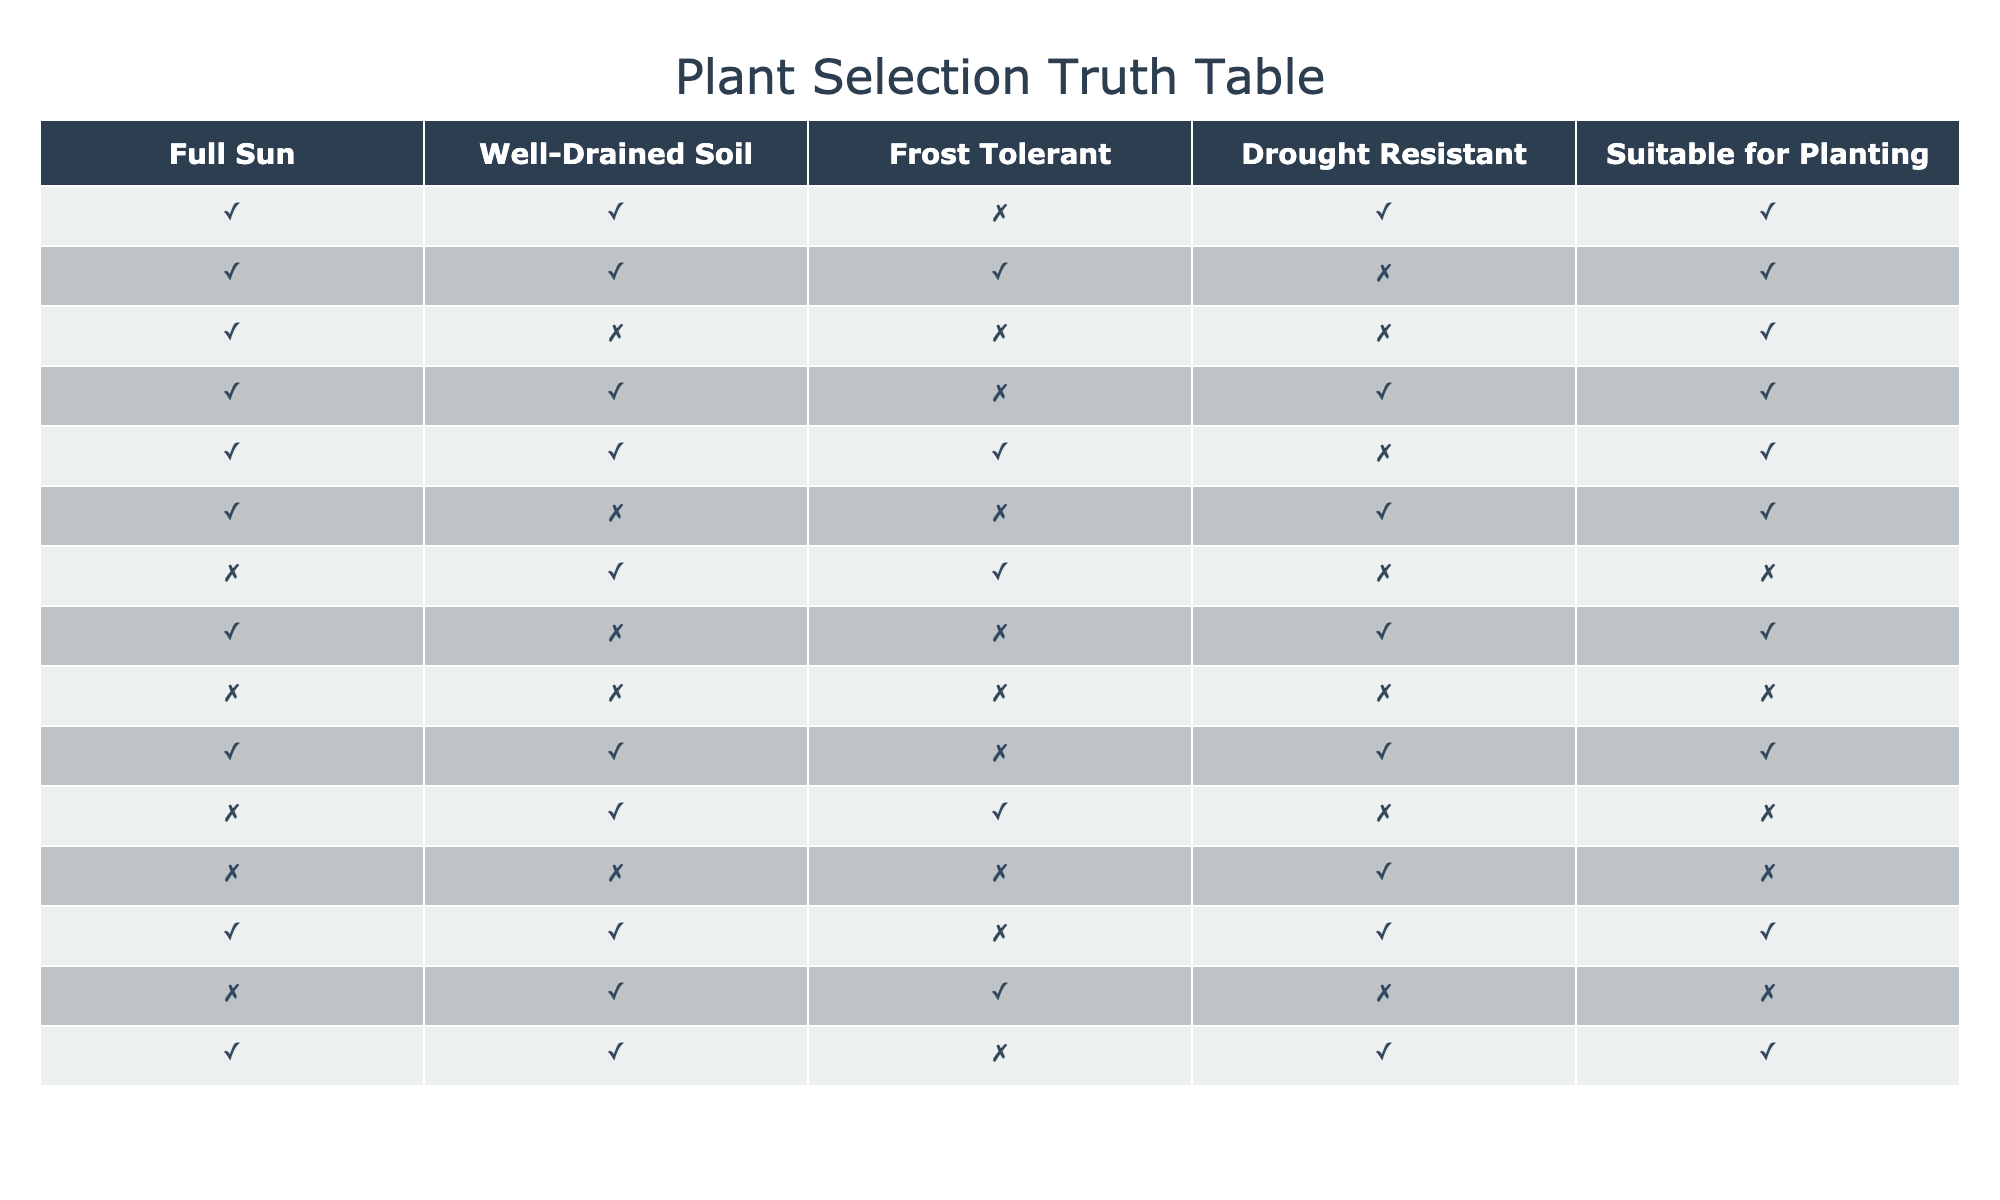What climate zones are suitable for planting with drought resistance? To find the climate zones that are suitable for planting with drought resistance, I look for the rows where "Drought Resistant" is true. The climate zones that fit this criterion are Mediterranean, Arid, Subtropical, Semi-Arid, Savanna, and Desert.
Answer: Mediterranean, Arid, Subtropical, Semi-Arid, Savanna, Desert Which climate zone does not tolerate frost and is not drought resistant? I need to check the criteria for "Frost Tolerant" being false and "Drought Resistant" also being false. The only climate zone that fits this condition is Tropical.
Answer: Tropical How many climate zones have well-drained soil and full sun exposure? I will count the climate zones where both "Well-Drained Soil" and "Full Sun" are true. The climate zones that meet this criteria are Mediterranean, Temperate, Arid, Coastal, Semi-Arid, and Savanna, totaling 6 climate zones.
Answer: 6 Is there any climate zone that meets all conditions except for drought resistance? I need to check for climate zones where "Full Sun", "Well-Drained Soil", and "Frost Tolerant" are all true, but "Drought Resistant" is false. The zones that satisfy this are Temperate and Continental.
Answer: Temperate, Continental Which climate zone has the most restrictions, with no suitable conditions for planting? I look for the climate zone where all conditions are false for planting suitability. In this case, the Rainforest zone is the only one where "Full Sun", "Well-Drained Soil", "Frost Tolerant", and "Drought Resistant" are all false.
Answer: Rainforest In which climate zone is frost tolerance present but drought resistance is absent? I examine the rows for climate zones where "Frost Tolerant" is true but "Drought Resistant" is false. The climate zones that satisfy this condition are Alpine and Boreal.
Answer: Alpine, Boreal Are there any climate zones that are suitable for planting but lack either frost tolerance or drought resistance? I need to find zones that are suitable for planting (where "Suitable for Planting" is true) but either "Frost Tolerant" or "Drought Resistant" is false. The climate zones that meet this criterion are Tropical, Subtropical, and Temperate.
Answer: Tropical, Subtropical, Temperate What is the total number of climate zones that are suitable for planting? I will count all the climate zones where "Suitable for Planting" is true. The total climate zones suitable for planting are 10: Mediterranean, Temperate, Tropical, Arid, Continental, Subtropical, Coastal, Semi-Arid, Savanna, and Desert.
Answer: 10 